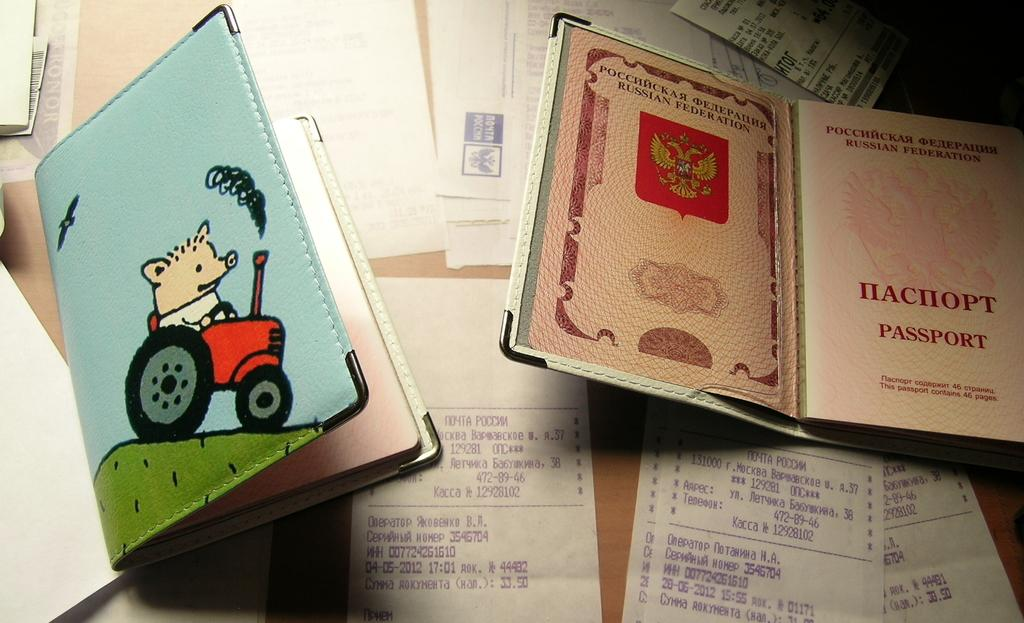<image>
Write a terse but informative summary of the picture. A passport cover is open, showing the word "passport" on the first page. 